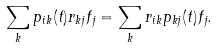<formula> <loc_0><loc_0><loc_500><loc_500>\sum _ { k } p _ { i k } ( t ) r _ { k j } f _ { j } = \sum _ { k } r _ { i k } p _ { k j } ( t ) f _ { j } .</formula> 